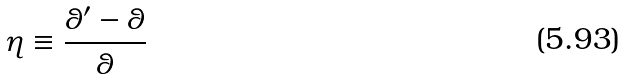<formula> <loc_0><loc_0><loc_500><loc_500>\eta \equiv \frac { \theta ^ { \prime } - \theta } { \theta }</formula> 